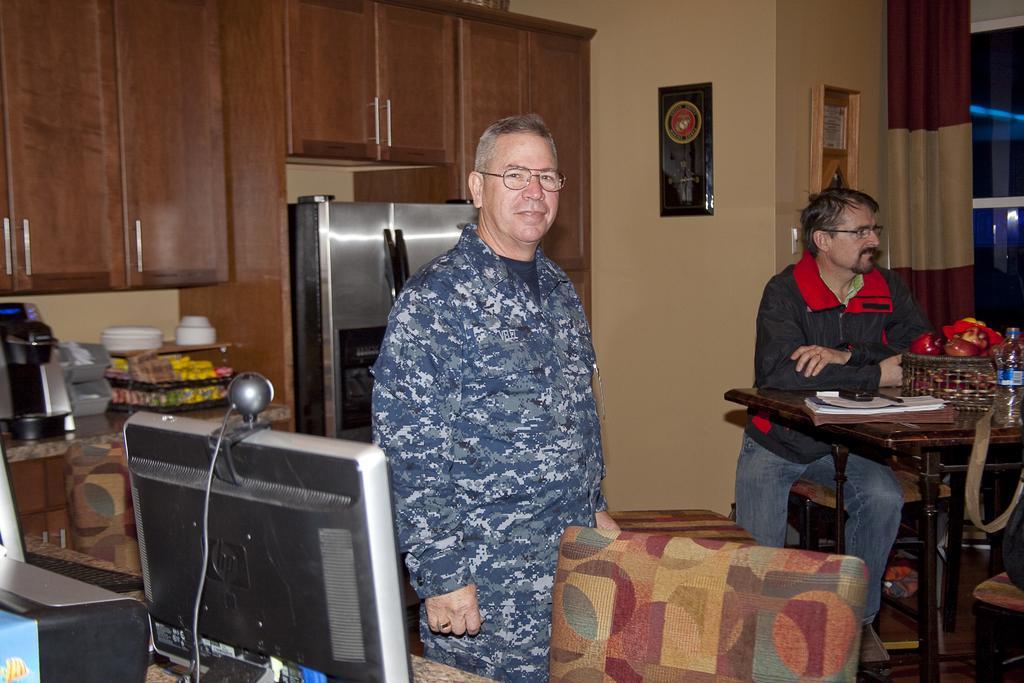Please provide a concise description of this image. In this picture there is a man in the center of the image and there is a monitor and a web camera on a table at the bottom side of the image and there is a chair at the bottom side of the image and there is another man who is sitting in front of a table on the right side of the image, there are cupboards, kitchenware, and a refrigerator in the background area of the image and there is window, curtain, and portraits in the image. 